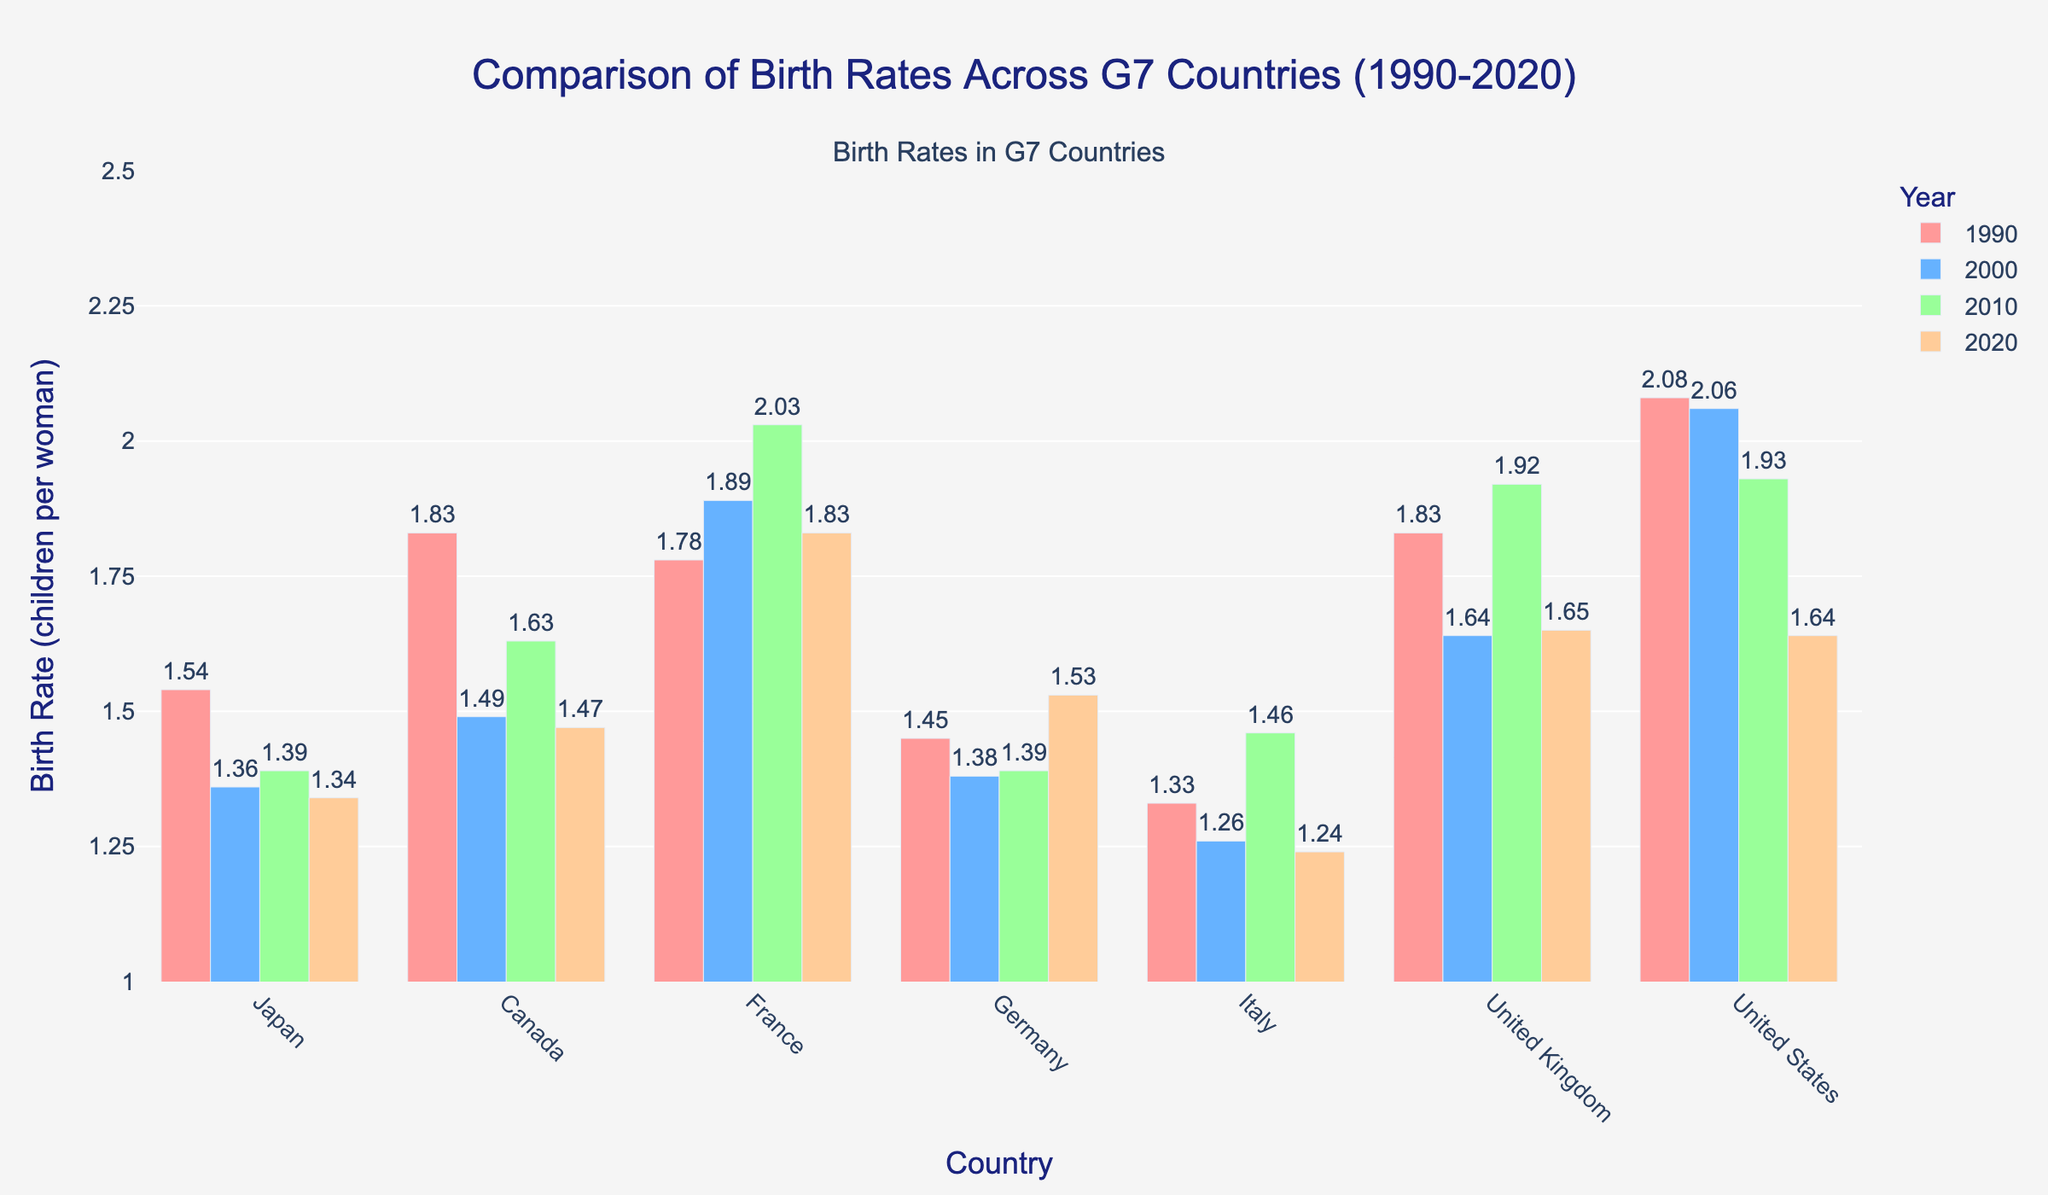What is the average birth rate in Japan from 1990 to 2020? To find the average, sum the birth rates for Japan across all years and divide by the number of years: (1.54 + 1.36 + 1.39 + 1.34) / 4 = 5.63 / 4 = 1.41
Answer: 1.41 Which country had the highest birth rate in 2020? By comparing the bars representing 2020 across all countries, the United States had the highest bar at 1.64
Answer: United States How did the birth rate in Italy change from 1990 to 2020? To find the change, subtract the birth rate in 1990 from the birth rate in 2020 for Italy: 1.24 - 1.33 = -0.09
Answer: -0.09 Which two countries had the closest birth rates in the year 2000? By comparing the bars for the year 2000, Germany and Japan had the closest birth rates at 1.38 and 1.36, respectively
Answer: Germany and Japan What is the percentage decrease in the birth rate of Canada from 1990 to 2020? Calculate the decrease and then convert it to a percentage: (1.83 - 1.47) / 1.83 * 100 = 0.36 / 1.83 * 100 ≈ 19.67%
Answer: 19.67% Between 1990 and 2020, which country showed the most significant increase in birth rate? By comparing the changes in birth rates for each country, Germany shows an increase from 1.45 to 1.53, which is the most significant positive change
Answer: Germany What is the median birth rate for all G7 countries in 2010? Extract the 2010 values, order them: {Japan: 1.39, Canada: 1.63, France: 2.03, Germany: 1.39, Italy: 1.46, UK: 1.92, US: 1.93}. The median is the middle value of the sorted list: 1.63
Answer: 1.63 Which country had the smallest birth rate in 2010, and what was it? By visually identifying the smallest bar for the year 2010, Japan and Germany both had the smallest birth rate at 1.39
Answer: Japan and Germany How many countries had lower birth rates in 2020 compared to 1990? By comparing the birth rates for 1990 and 2020 for each country, 5 countries (Japan, Canada, Italy, United Kingdom, and the United States) had lower birth rates in 2020
Answer: 5 